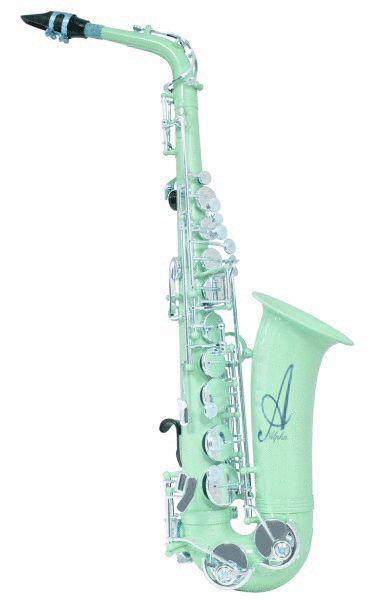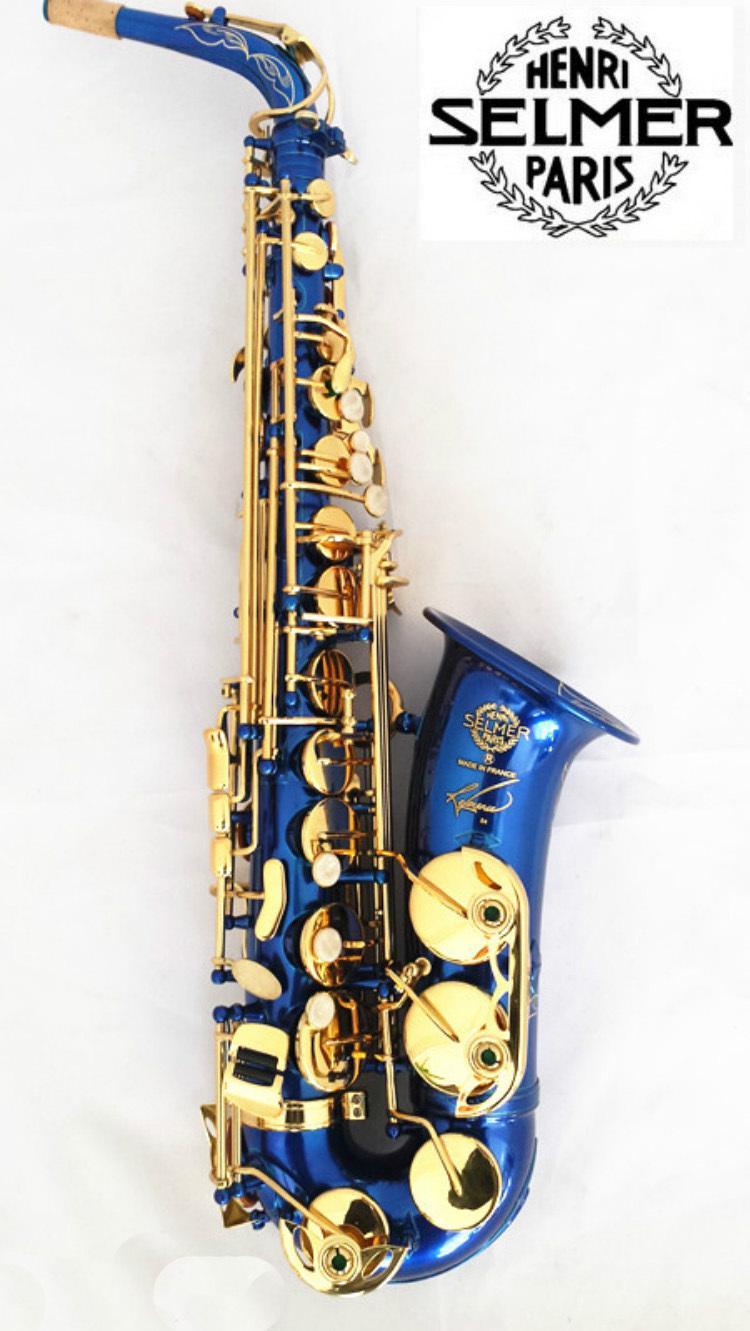The first image is the image on the left, the second image is the image on the right. For the images displayed, is the sentence "Both of the saxophones are set up in the same position." factually correct? Answer yes or no. Yes. The first image is the image on the left, the second image is the image on the right. Given the left and right images, does the statement "At least one saxophone is not a traditional metal color." hold true? Answer yes or no. Yes. 